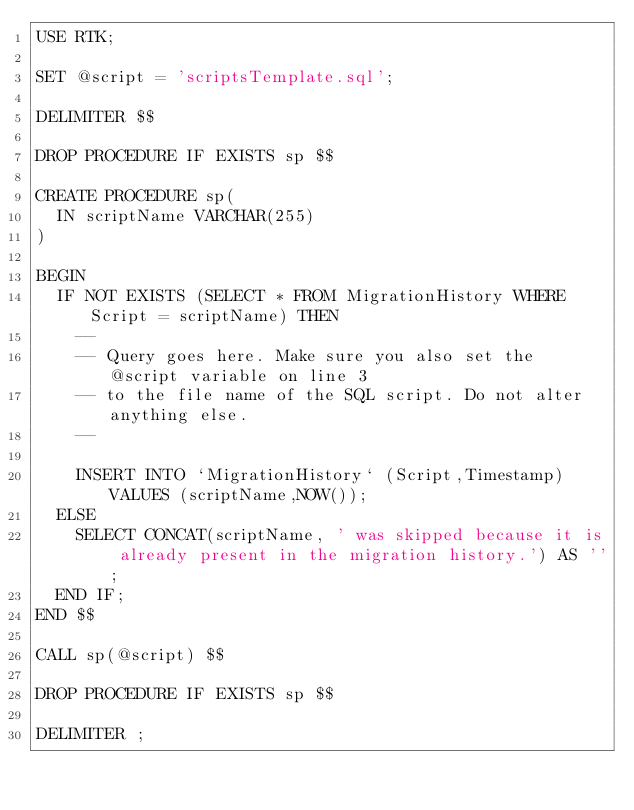Convert code to text. <code><loc_0><loc_0><loc_500><loc_500><_SQL_>USE RTK;

SET @script = 'scriptsTemplate.sql';

DELIMITER $$

DROP PROCEDURE IF EXISTS sp $$

CREATE PROCEDURE sp(
	IN scriptName VARCHAR(255)
)

BEGIN
	IF NOT EXISTS (SELECT * FROM MigrationHistory WHERE Script = scriptName) THEN
		--
		-- Query goes here. Make sure you also set the @script variable on line 3
		-- to the file name of the SQL script. Do not alter anything else.
		--

		INSERT INTO `MigrationHistory` (Script,Timestamp) VALUES (scriptName,NOW());
	ELSE
		SELECT CONCAT(scriptName, ' was skipped because it is already present in the migration history.') AS '';
	END IF;
END $$

CALL sp(@script) $$

DROP PROCEDURE IF EXISTS sp $$
 
DELIMITER ;
</code> 